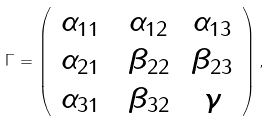<formula> <loc_0><loc_0><loc_500><loc_500>\Gamma = \left ( \begin{array} { c c c } \alpha _ { 1 1 } \, & \, \alpha _ { 1 2 } & \, \alpha _ { 1 3 } \\ \alpha _ { 2 1 } \, & \, \beta _ { 2 2 } & \, \beta _ { 2 3 } \\ \alpha _ { 3 1 } \, & \, \beta _ { 3 2 } & \, \gamma \end{array} \right ) ,</formula> 